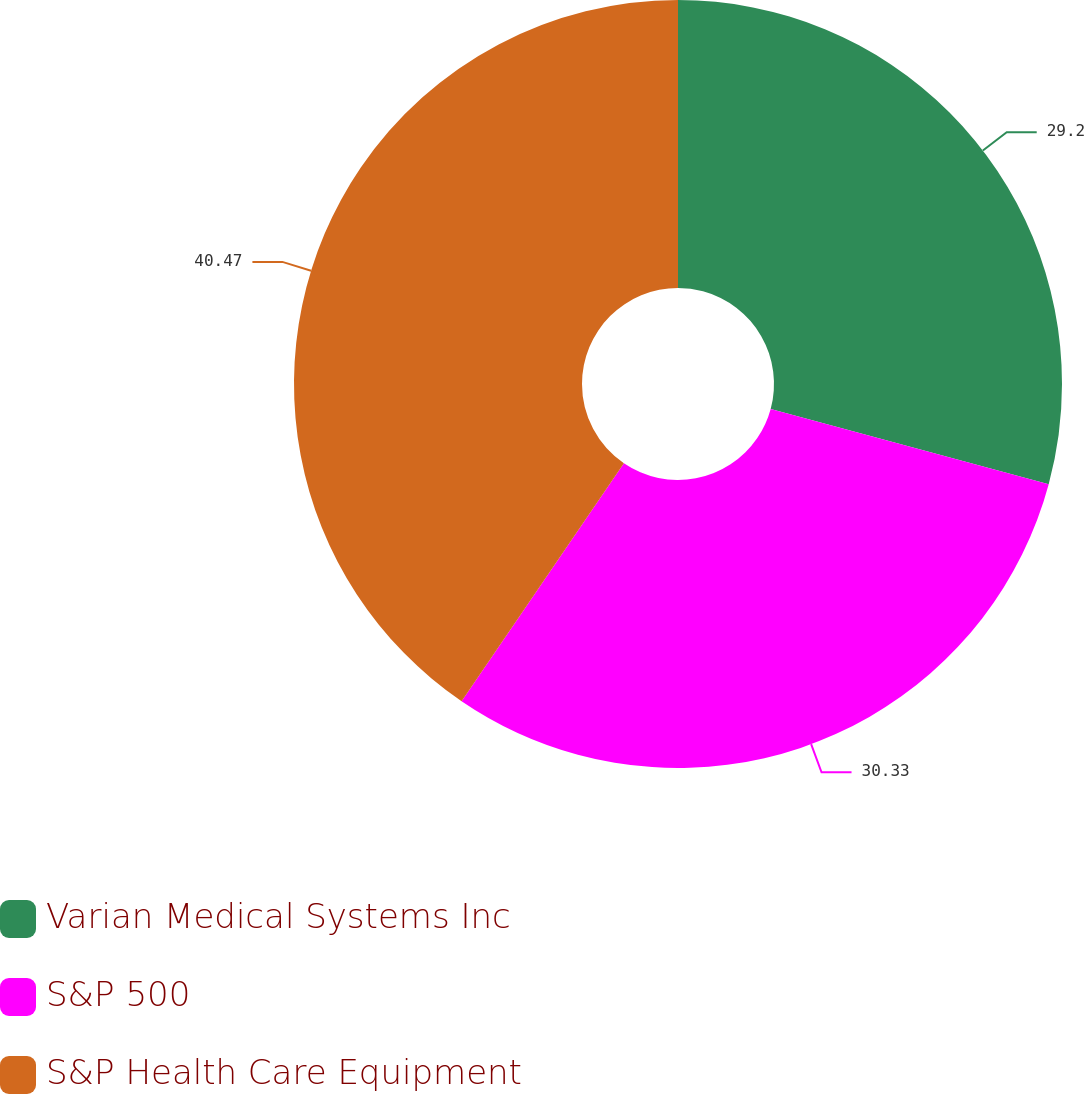<chart> <loc_0><loc_0><loc_500><loc_500><pie_chart><fcel>Varian Medical Systems Inc<fcel>S&P 500<fcel>S&P Health Care Equipment<nl><fcel>29.2%<fcel>30.33%<fcel>40.47%<nl></chart> 